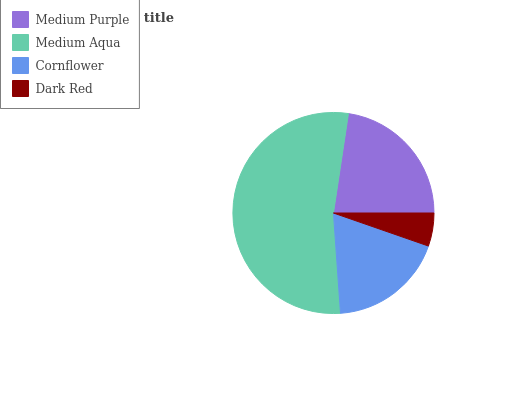Is Dark Red the minimum?
Answer yes or no. Yes. Is Medium Aqua the maximum?
Answer yes or no. Yes. Is Cornflower the minimum?
Answer yes or no. No. Is Cornflower the maximum?
Answer yes or no. No. Is Medium Aqua greater than Cornflower?
Answer yes or no. Yes. Is Cornflower less than Medium Aqua?
Answer yes or no. Yes. Is Cornflower greater than Medium Aqua?
Answer yes or no. No. Is Medium Aqua less than Cornflower?
Answer yes or no. No. Is Medium Purple the high median?
Answer yes or no. Yes. Is Cornflower the low median?
Answer yes or no. Yes. Is Dark Red the high median?
Answer yes or no. No. Is Medium Aqua the low median?
Answer yes or no. No. 